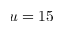<formula> <loc_0><loc_0><loc_500><loc_500>u = 1 5</formula> 